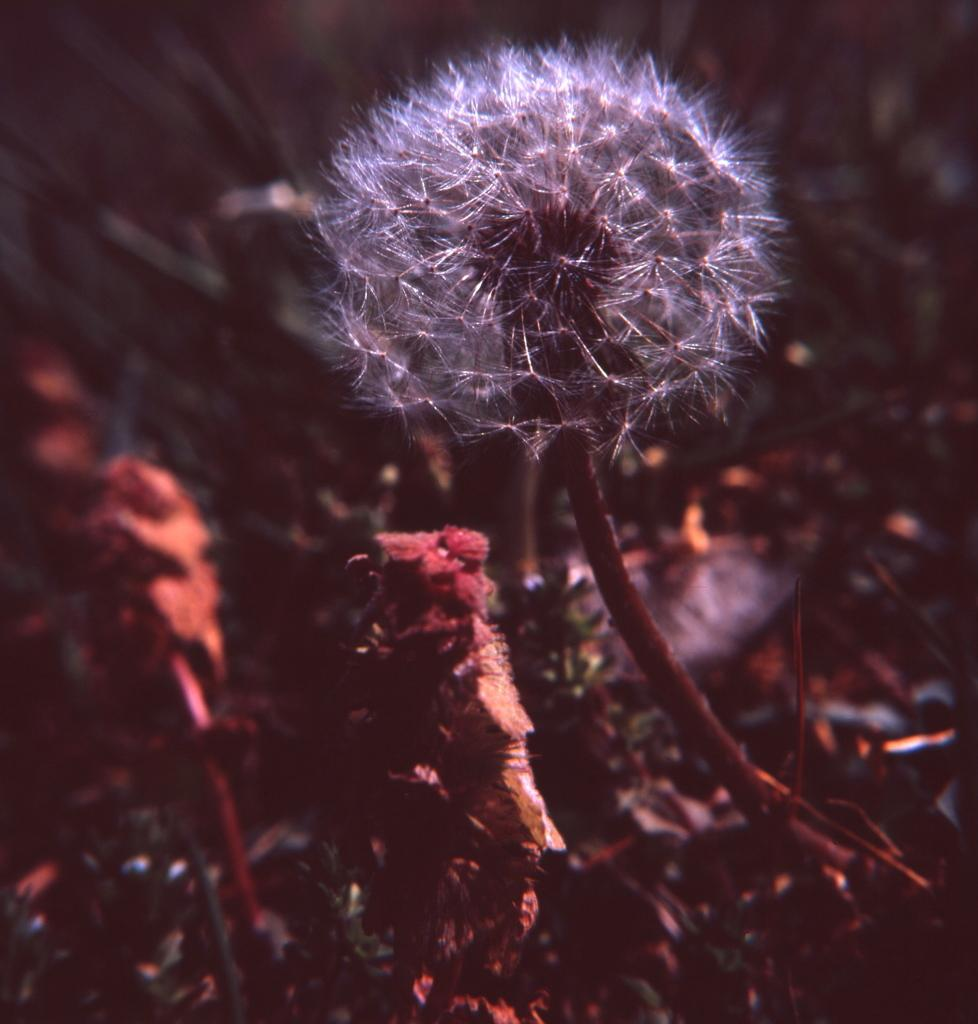What is the main subject of the image? There is an object that resembles a flower in the image. What can be observed about the background of the image? The background of the image is dark. What type of experience can be seen happening at the party in the image? There is no party or experience present in the image; it features an object that resembles a flower with a dark background. 